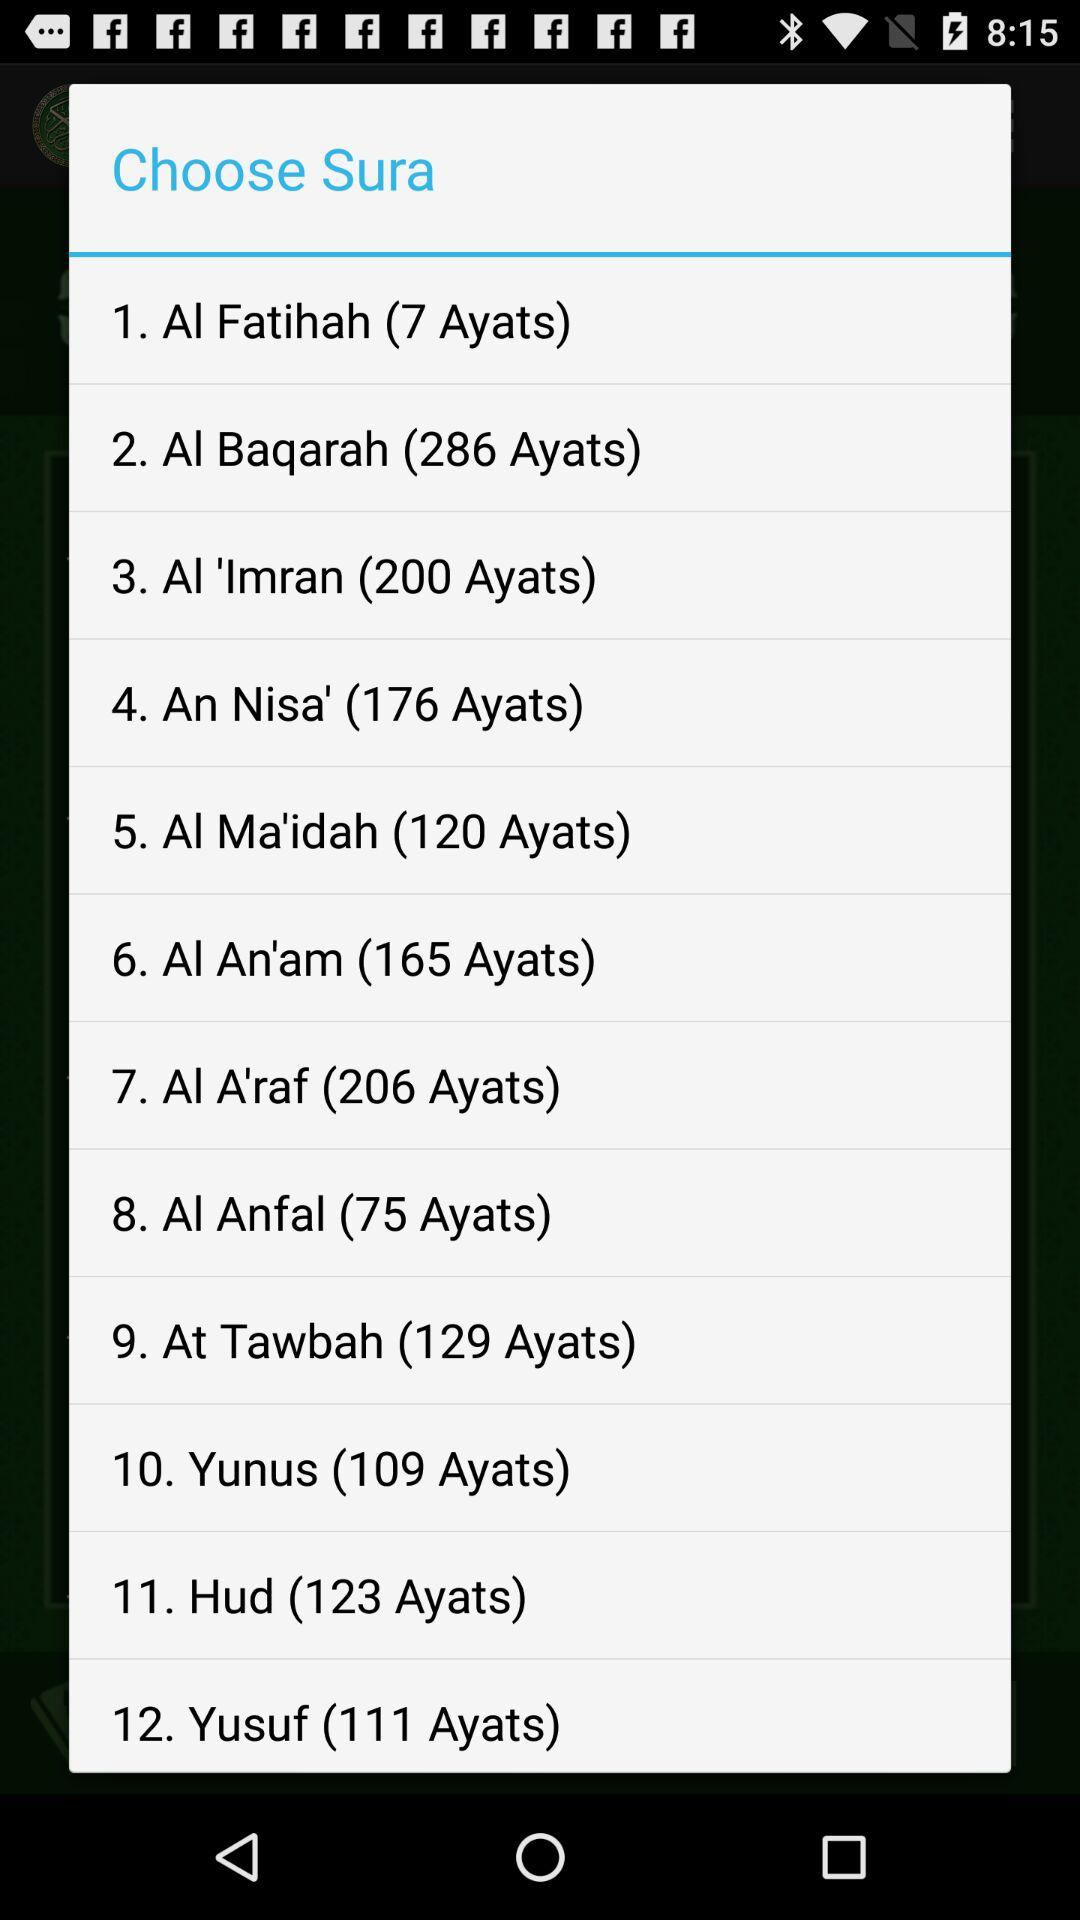What is the number of ayats in "Yunus"? The number of ayats in "Yunus" is 109. 